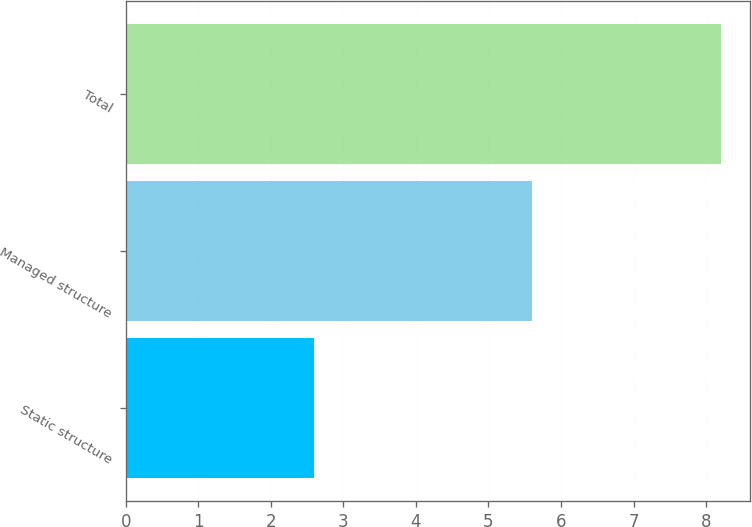Convert chart. <chart><loc_0><loc_0><loc_500><loc_500><bar_chart><fcel>Static structure<fcel>Managed structure<fcel>Total<nl><fcel>2.6<fcel>5.6<fcel>8.2<nl></chart> 